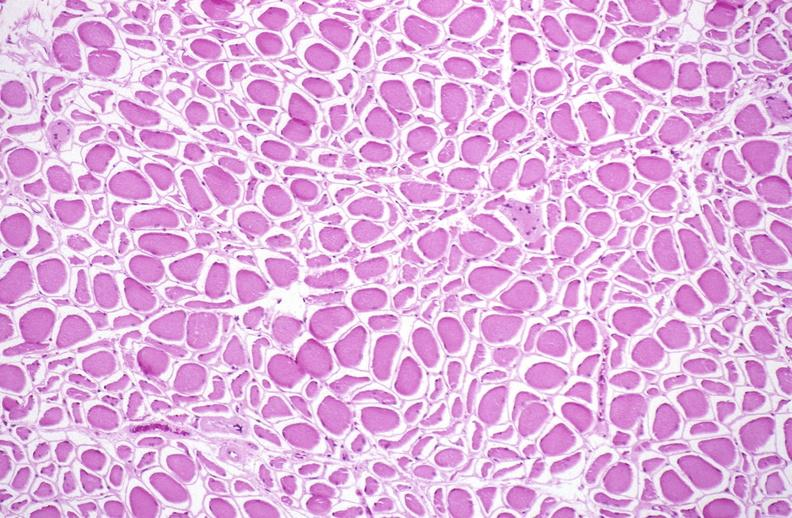s soft tissue present?
Answer the question using a single word or phrase. Yes 